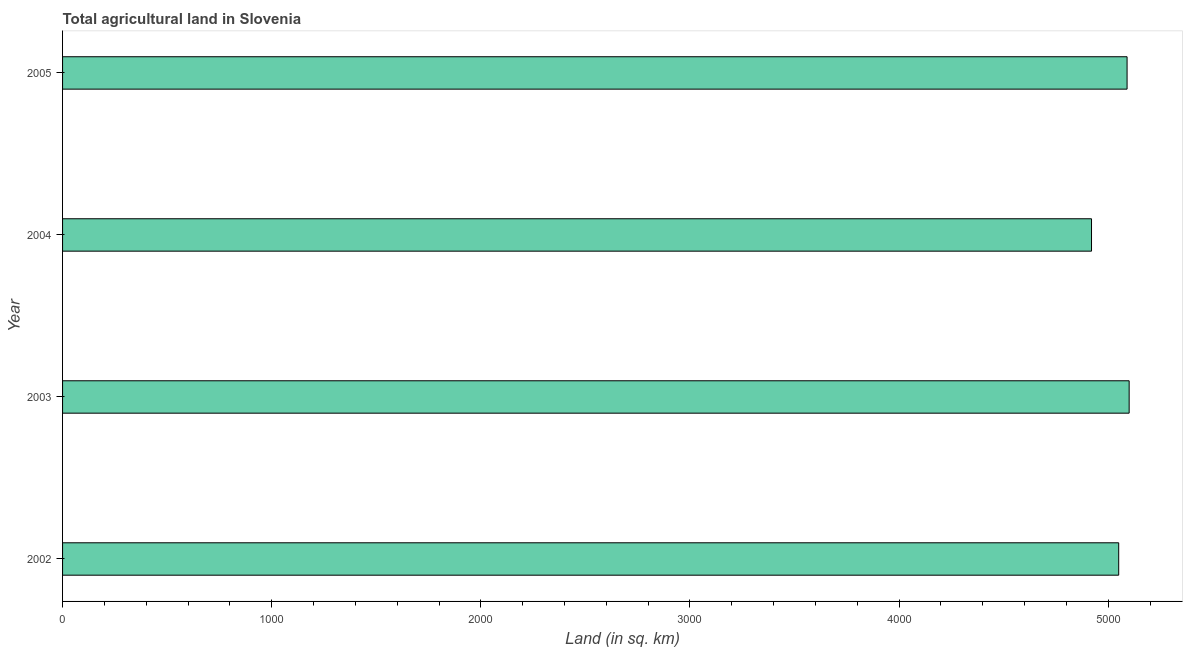Does the graph contain grids?
Offer a very short reply. No. What is the title of the graph?
Your answer should be very brief. Total agricultural land in Slovenia. What is the label or title of the X-axis?
Provide a short and direct response. Land (in sq. km). What is the label or title of the Y-axis?
Offer a terse response. Year. What is the agricultural land in 2003?
Your answer should be very brief. 5100. Across all years, what is the maximum agricultural land?
Make the answer very short. 5100. Across all years, what is the minimum agricultural land?
Offer a terse response. 4920. In which year was the agricultural land minimum?
Keep it short and to the point. 2004. What is the sum of the agricultural land?
Provide a succinct answer. 2.02e+04. What is the difference between the agricultural land in 2003 and 2004?
Give a very brief answer. 180. What is the average agricultural land per year?
Offer a terse response. 5040. What is the median agricultural land?
Your answer should be compact. 5070. Is the difference between the agricultural land in 2003 and 2005 greater than the difference between any two years?
Provide a succinct answer. No. Is the sum of the agricultural land in 2002 and 2005 greater than the maximum agricultural land across all years?
Ensure brevity in your answer.  Yes. What is the difference between the highest and the lowest agricultural land?
Keep it short and to the point. 180. What is the difference between two consecutive major ticks on the X-axis?
Your response must be concise. 1000. Are the values on the major ticks of X-axis written in scientific E-notation?
Make the answer very short. No. What is the Land (in sq. km) of 2002?
Offer a very short reply. 5050. What is the Land (in sq. km) in 2003?
Offer a very short reply. 5100. What is the Land (in sq. km) in 2004?
Make the answer very short. 4920. What is the Land (in sq. km) of 2005?
Give a very brief answer. 5090. What is the difference between the Land (in sq. km) in 2002 and 2003?
Keep it short and to the point. -50. What is the difference between the Land (in sq. km) in 2002 and 2004?
Your response must be concise. 130. What is the difference between the Land (in sq. km) in 2002 and 2005?
Your answer should be very brief. -40. What is the difference between the Land (in sq. km) in 2003 and 2004?
Your answer should be very brief. 180. What is the difference between the Land (in sq. km) in 2003 and 2005?
Give a very brief answer. 10. What is the difference between the Land (in sq. km) in 2004 and 2005?
Keep it short and to the point. -170. What is the ratio of the Land (in sq. km) in 2002 to that in 2003?
Your answer should be very brief. 0.99. What is the ratio of the Land (in sq. km) in 2002 to that in 2004?
Provide a succinct answer. 1.03. What is the ratio of the Land (in sq. km) in 2002 to that in 2005?
Offer a terse response. 0.99. What is the ratio of the Land (in sq. km) in 2003 to that in 2004?
Offer a very short reply. 1.04. 